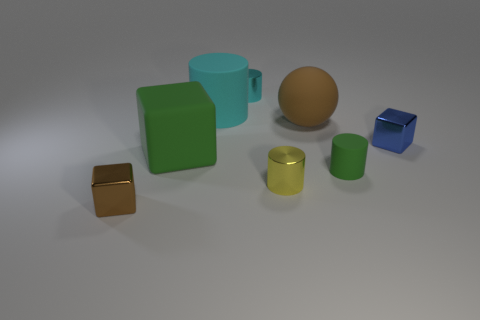Reflecting on the arrangement, what kind of setting could this be a representation of? This arrangement might represent a simplistic and idealized tabletop display in a study or workspace, where different geometric shapes are organized for visual or educational purposes. 